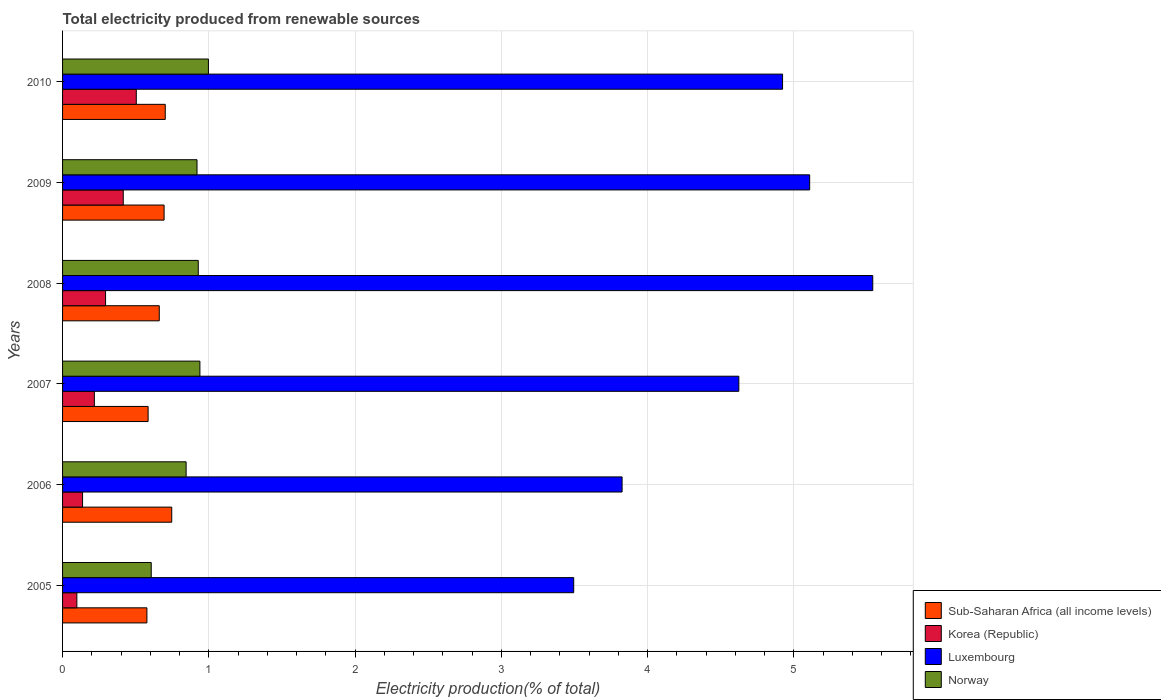How many different coloured bars are there?
Make the answer very short. 4. How many groups of bars are there?
Your answer should be very brief. 6. Are the number of bars per tick equal to the number of legend labels?
Provide a succinct answer. Yes. Are the number of bars on each tick of the Y-axis equal?
Your answer should be very brief. Yes. How many bars are there on the 2nd tick from the bottom?
Keep it short and to the point. 4. In how many cases, is the number of bars for a given year not equal to the number of legend labels?
Offer a very short reply. 0. What is the total electricity produced in Sub-Saharan Africa (all income levels) in 2006?
Provide a succinct answer. 0.75. Across all years, what is the maximum total electricity produced in Luxembourg?
Provide a succinct answer. 5.54. Across all years, what is the minimum total electricity produced in Luxembourg?
Your response must be concise. 3.49. What is the total total electricity produced in Norway in the graph?
Make the answer very short. 5.23. What is the difference between the total electricity produced in Norway in 2006 and that in 2007?
Ensure brevity in your answer.  -0.09. What is the difference between the total electricity produced in Sub-Saharan Africa (all income levels) in 2005 and the total electricity produced in Korea (Republic) in 2007?
Your response must be concise. 0.36. What is the average total electricity produced in Korea (Republic) per year?
Provide a succinct answer. 0.28. In the year 2009, what is the difference between the total electricity produced in Luxembourg and total electricity produced in Sub-Saharan Africa (all income levels)?
Your response must be concise. 4.41. In how many years, is the total electricity produced in Luxembourg greater than 1.6 %?
Offer a terse response. 6. What is the ratio of the total electricity produced in Sub-Saharan Africa (all income levels) in 2007 to that in 2009?
Keep it short and to the point. 0.84. What is the difference between the highest and the second highest total electricity produced in Norway?
Your answer should be very brief. 0.06. What is the difference between the highest and the lowest total electricity produced in Luxembourg?
Your response must be concise. 2.04. In how many years, is the total electricity produced in Luxembourg greater than the average total electricity produced in Luxembourg taken over all years?
Provide a succinct answer. 4. What does the 2nd bar from the top in 2009 represents?
Ensure brevity in your answer.  Luxembourg. What does the 3rd bar from the bottom in 2010 represents?
Ensure brevity in your answer.  Luxembourg. Is it the case that in every year, the sum of the total electricity produced in Luxembourg and total electricity produced in Korea (Republic) is greater than the total electricity produced in Sub-Saharan Africa (all income levels)?
Your answer should be very brief. Yes. How many bars are there?
Make the answer very short. 24. Does the graph contain any zero values?
Ensure brevity in your answer.  No. Where does the legend appear in the graph?
Provide a short and direct response. Bottom right. How many legend labels are there?
Make the answer very short. 4. What is the title of the graph?
Provide a succinct answer. Total electricity produced from renewable sources. Does "East Asia (all income levels)" appear as one of the legend labels in the graph?
Offer a terse response. No. What is the label or title of the Y-axis?
Make the answer very short. Years. What is the Electricity production(% of total) of Sub-Saharan Africa (all income levels) in 2005?
Keep it short and to the point. 0.58. What is the Electricity production(% of total) of Korea (Republic) in 2005?
Ensure brevity in your answer.  0.1. What is the Electricity production(% of total) of Luxembourg in 2005?
Provide a short and direct response. 3.49. What is the Electricity production(% of total) of Norway in 2005?
Your answer should be compact. 0.61. What is the Electricity production(% of total) in Sub-Saharan Africa (all income levels) in 2006?
Offer a terse response. 0.75. What is the Electricity production(% of total) of Korea (Republic) in 2006?
Give a very brief answer. 0.14. What is the Electricity production(% of total) in Luxembourg in 2006?
Your answer should be very brief. 3.83. What is the Electricity production(% of total) in Norway in 2006?
Provide a short and direct response. 0.84. What is the Electricity production(% of total) of Sub-Saharan Africa (all income levels) in 2007?
Your answer should be compact. 0.58. What is the Electricity production(% of total) in Korea (Republic) in 2007?
Keep it short and to the point. 0.22. What is the Electricity production(% of total) of Luxembourg in 2007?
Give a very brief answer. 4.62. What is the Electricity production(% of total) of Norway in 2007?
Offer a very short reply. 0.94. What is the Electricity production(% of total) of Sub-Saharan Africa (all income levels) in 2008?
Give a very brief answer. 0.66. What is the Electricity production(% of total) in Korea (Republic) in 2008?
Your answer should be very brief. 0.29. What is the Electricity production(% of total) in Luxembourg in 2008?
Your answer should be very brief. 5.54. What is the Electricity production(% of total) in Norway in 2008?
Provide a succinct answer. 0.93. What is the Electricity production(% of total) of Sub-Saharan Africa (all income levels) in 2009?
Keep it short and to the point. 0.69. What is the Electricity production(% of total) of Korea (Republic) in 2009?
Give a very brief answer. 0.41. What is the Electricity production(% of total) in Luxembourg in 2009?
Ensure brevity in your answer.  5.11. What is the Electricity production(% of total) of Norway in 2009?
Your answer should be compact. 0.92. What is the Electricity production(% of total) in Sub-Saharan Africa (all income levels) in 2010?
Give a very brief answer. 0.7. What is the Electricity production(% of total) in Korea (Republic) in 2010?
Your response must be concise. 0.5. What is the Electricity production(% of total) in Luxembourg in 2010?
Make the answer very short. 4.92. What is the Electricity production(% of total) in Norway in 2010?
Provide a succinct answer. 1. Across all years, what is the maximum Electricity production(% of total) of Sub-Saharan Africa (all income levels)?
Make the answer very short. 0.75. Across all years, what is the maximum Electricity production(% of total) in Korea (Republic)?
Provide a succinct answer. 0.5. Across all years, what is the maximum Electricity production(% of total) of Luxembourg?
Provide a short and direct response. 5.54. Across all years, what is the maximum Electricity production(% of total) in Norway?
Provide a succinct answer. 1. Across all years, what is the minimum Electricity production(% of total) of Sub-Saharan Africa (all income levels)?
Provide a succinct answer. 0.58. Across all years, what is the minimum Electricity production(% of total) in Korea (Republic)?
Make the answer very short. 0.1. Across all years, what is the minimum Electricity production(% of total) in Luxembourg?
Offer a terse response. 3.49. Across all years, what is the minimum Electricity production(% of total) of Norway?
Provide a short and direct response. 0.61. What is the total Electricity production(% of total) in Sub-Saharan Africa (all income levels) in the graph?
Offer a terse response. 3.97. What is the total Electricity production(% of total) in Korea (Republic) in the graph?
Your answer should be very brief. 1.66. What is the total Electricity production(% of total) in Luxembourg in the graph?
Your response must be concise. 27.51. What is the total Electricity production(% of total) in Norway in the graph?
Offer a terse response. 5.23. What is the difference between the Electricity production(% of total) in Sub-Saharan Africa (all income levels) in 2005 and that in 2006?
Your response must be concise. -0.17. What is the difference between the Electricity production(% of total) of Korea (Republic) in 2005 and that in 2006?
Your answer should be compact. -0.04. What is the difference between the Electricity production(% of total) in Luxembourg in 2005 and that in 2006?
Offer a terse response. -0.33. What is the difference between the Electricity production(% of total) of Norway in 2005 and that in 2006?
Your response must be concise. -0.24. What is the difference between the Electricity production(% of total) in Sub-Saharan Africa (all income levels) in 2005 and that in 2007?
Make the answer very short. -0.01. What is the difference between the Electricity production(% of total) in Korea (Republic) in 2005 and that in 2007?
Your response must be concise. -0.12. What is the difference between the Electricity production(% of total) in Luxembourg in 2005 and that in 2007?
Your answer should be compact. -1.13. What is the difference between the Electricity production(% of total) in Norway in 2005 and that in 2007?
Your answer should be compact. -0.33. What is the difference between the Electricity production(% of total) of Sub-Saharan Africa (all income levels) in 2005 and that in 2008?
Ensure brevity in your answer.  -0.08. What is the difference between the Electricity production(% of total) in Korea (Republic) in 2005 and that in 2008?
Offer a terse response. -0.2. What is the difference between the Electricity production(% of total) in Luxembourg in 2005 and that in 2008?
Your answer should be very brief. -2.04. What is the difference between the Electricity production(% of total) in Norway in 2005 and that in 2008?
Provide a short and direct response. -0.32. What is the difference between the Electricity production(% of total) in Sub-Saharan Africa (all income levels) in 2005 and that in 2009?
Your answer should be very brief. -0.12. What is the difference between the Electricity production(% of total) in Korea (Republic) in 2005 and that in 2009?
Provide a short and direct response. -0.32. What is the difference between the Electricity production(% of total) in Luxembourg in 2005 and that in 2009?
Provide a short and direct response. -1.61. What is the difference between the Electricity production(% of total) of Norway in 2005 and that in 2009?
Provide a short and direct response. -0.31. What is the difference between the Electricity production(% of total) of Sub-Saharan Africa (all income levels) in 2005 and that in 2010?
Give a very brief answer. -0.13. What is the difference between the Electricity production(% of total) in Korea (Republic) in 2005 and that in 2010?
Give a very brief answer. -0.41. What is the difference between the Electricity production(% of total) of Luxembourg in 2005 and that in 2010?
Your response must be concise. -1.43. What is the difference between the Electricity production(% of total) in Norway in 2005 and that in 2010?
Your answer should be compact. -0.39. What is the difference between the Electricity production(% of total) in Sub-Saharan Africa (all income levels) in 2006 and that in 2007?
Your answer should be compact. 0.16. What is the difference between the Electricity production(% of total) of Korea (Republic) in 2006 and that in 2007?
Your answer should be compact. -0.08. What is the difference between the Electricity production(% of total) in Luxembourg in 2006 and that in 2007?
Your answer should be very brief. -0.8. What is the difference between the Electricity production(% of total) in Norway in 2006 and that in 2007?
Offer a terse response. -0.09. What is the difference between the Electricity production(% of total) in Sub-Saharan Africa (all income levels) in 2006 and that in 2008?
Keep it short and to the point. 0.09. What is the difference between the Electricity production(% of total) in Korea (Republic) in 2006 and that in 2008?
Keep it short and to the point. -0.16. What is the difference between the Electricity production(% of total) in Luxembourg in 2006 and that in 2008?
Offer a very short reply. -1.71. What is the difference between the Electricity production(% of total) in Norway in 2006 and that in 2008?
Provide a short and direct response. -0.08. What is the difference between the Electricity production(% of total) in Sub-Saharan Africa (all income levels) in 2006 and that in 2009?
Provide a short and direct response. 0.05. What is the difference between the Electricity production(% of total) of Korea (Republic) in 2006 and that in 2009?
Offer a terse response. -0.28. What is the difference between the Electricity production(% of total) of Luxembourg in 2006 and that in 2009?
Offer a very short reply. -1.28. What is the difference between the Electricity production(% of total) of Norway in 2006 and that in 2009?
Give a very brief answer. -0.07. What is the difference between the Electricity production(% of total) of Sub-Saharan Africa (all income levels) in 2006 and that in 2010?
Provide a short and direct response. 0.04. What is the difference between the Electricity production(% of total) in Korea (Republic) in 2006 and that in 2010?
Offer a very short reply. -0.37. What is the difference between the Electricity production(% of total) of Luxembourg in 2006 and that in 2010?
Make the answer very short. -1.1. What is the difference between the Electricity production(% of total) in Norway in 2006 and that in 2010?
Your response must be concise. -0.15. What is the difference between the Electricity production(% of total) in Sub-Saharan Africa (all income levels) in 2007 and that in 2008?
Your answer should be very brief. -0.08. What is the difference between the Electricity production(% of total) of Korea (Republic) in 2007 and that in 2008?
Your answer should be very brief. -0.08. What is the difference between the Electricity production(% of total) in Luxembourg in 2007 and that in 2008?
Provide a succinct answer. -0.92. What is the difference between the Electricity production(% of total) of Norway in 2007 and that in 2008?
Provide a short and direct response. 0.01. What is the difference between the Electricity production(% of total) of Sub-Saharan Africa (all income levels) in 2007 and that in 2009?
Offer a very short reply. -0.11. What is the difference between the Electricity production(% of total) in Korea (Republic) in 2007 and that in 2009?
Ensure brevity in your answer.  -0.2. What is the difference between the Electricity production(% of total) in Luxembourg in 2007 and that in 2009?
Keep it short and to the point. -0.48. What is the difference between the Electricity production(% of total) of Norway in 2007 and that in 2009?
Ensure brevity in your answer.  0.02. What is the difference between the Electricity production(% of total) in Sub-Saharan Africa (all income levels) in 2007 and that in 2010?
Provide a short and direct response. -0.12. What is the difference between the Electricity production(% of total) in Korea (Republic) in 2007 and that in 2010?
Your answer should be very brief. -0.29. What is the difference between the Electricity production(% of total) of Luxembourg in 2007 and that in 2010?
Make the answer very short. -0.3. What is the difference between the Electricity production(% of total) in Norway in 2007 and that in 2010?
Keep it short and to the point. -0.06. What is the difference between the Electricity production(% of total) of Sub-Saharan Africa (all income levels) in 2008 and that in 2009?
Ensure brevity in your answer.  -0.03. What is the difference between the Electricity production(% of total) of Korea (Republic) in 2008 and that in 2009?
Provide a short and direct response. -0.12. What is the difference between the Electricity production(% of total) of Luxembourg in 2008 and that in 2009?
Your response must be concise. 0.43. What is the difference between the Electricity production(% of total) of Norway in 2008 and that in 2009?
Give a very brief answer. 0.01. What is the difference between the Electricity production(% of total) of Sub-Saharan Africa (all income levels) in 2008 and that in 2010?
Offer a very short reply. -0.04. What is the difference between the Electricity production(% of total) of Korea (Republic) in 2008 and that in 2010?
Provide a succinct answer. -0.21. What is the difference between the Electricity production(% of total) in Luxembourg in 2008 and that in 2010?
Make the answer very short. 0.62. What is the difference between the Electricity production(% of total) of Norway in 2008 and that in 2010?
Your answer should be very brief. -0.07. What is the difference between the Electricity production(% of total) in Sub-Saharan Africa (all income levels) in 2009 and that in 2010?
Keep it short and to the point. -0.01. What is the difference between the Electricity production(% of total) of Korea (Republic) in 2009 and that in 2010?
Ensure brevity in your answer.  -0.09. What is the difference between the Electricity production(% of total) in Luxembourg in 2009 and that in 2010?
Ensure brevity in your answer.  0.19. What is the difference between the Electricity production(% of total) of Norway in 2009 and that in 2010?
Your response must be concise. -0.08. What is the difference between the Electricity production(% of total) in Sub-Saharan Africa (all income levels) in 2005 and the Electricity production(% of total) in Korea (Republic) in 2006?
Your answer should be compact. 0.44. What is the difference between the Electricity production(% of total) in Sub-Saharan Africa (all income levels) in 2005 and the Electricity production(% of total) in Luxembourg in 2006?
Give a very brief answer. -3.25. What is the difference between the Electricity production(% of total) of Sub-Saharan Africa (all income levels) in 2005 and the Electricity production(% of total) of Norway in 2006?
Provide a short and direct response. -0.27. What is the difference between the Electricity production(% of total) in Korea (Republic) in 2005 and the Electricity production(% of total) in Luxembourg in 2006?
Offer a terse response. -3.73. What is the difference between the Electricity production(% of total) of Korea (Republic) in 2005 and the Electricity production(% of total) of Norway in 2006?
Offer a very short reply. -0.75. What is the difference between the Electricity production(% of total) in Luxembourg in 2005 and the Electricity production(% of total) in Norway in 2006?
Your answer should be very brief. 2.65. What is the difference between the Electricity production(% of total) of Sub-Saharan Africa (all income levels) in 2005 and the Electricity production(% of total) of Korea (Republic) in 2007?
Make the answer very short. 0.36. What is the difference between the Electricity production(% of total) in Sub-Saharan Africa (all income levels) in 2005 and the Electricity production(% of total) in Luxembourg in 2007?
Your response must be concise. -4.05. What is the difference between the Electricity production(% of total) in Sub-Saharan Africa (all income levels) in 2005 and the Electricity production(% of total) in Norway in 2007?
Your response must be concise. -0.36. What is the difference between the Electricity production(% of total) of Korea (Republic) in 2005 and the Electricity production(% of total) of Luxembourg in 2007?
Your answer should be compact. -4.53. What is the difference between the Electricity production(% of total) in Korea (Republic) in 2005 and the Electricity production(% of total) in Norway in 2007?
Give a very brief answer. -0.84. What is the difference between the Electricity production(% of total) in Luxembourg in 2005 and the Electricity production(% of total) in Norway in 2007?
Provide a succinct answer. 2.56. What is the difference between the Electricity production(% of total) in Sub-Saharan Africa (all income levels) in 2005 and the Electricity production(% of total) in Korea (Republic) in 2008?
Offer a terse response. 0.28. What is the difference between the Electricity production(% of total) in Sub-Saharan Africa (all income levels) in 2005 and the Electricity production(% of total) in Luxembourg in 2008?
Provide a short and direct response. -4.96. What is the difference between the Electricity production(% of total) in Sub-Saharan Africa (all income levels) in 2005 and the Electricity production(% of total) in Norway in 2008?
Keep it short and to the point. -0.35. What is the difference between the Electricity production(% of total) of Korea (Republic) in 2005 and the Electricity production(% of total) of Luxembourg in 2008?
Offer a very short reply. -5.44. What is the difference between the Electricity production(% of total) of Korea (Republic) in 2005 and the Electricity production(% of total) of Norway in 2008?
Your answer should be very brief. -0.83. What is the difference between the Electricity production(% of total) in Luxembourg in 2005 and the Electricity production(% of total) in Norway in 2008?
Keep it short and to the point. 2.57. What is the difference between the Electricity production(% of total) of Sub-Saharan Africa (all income levels) in 2005 and the Electricity production(% of total) of Korea (Republic) in 2009?
Offer a terse response. 0.16. What is the difference between the Electricity production(% of total) in Sub-Saharan Africa (all income levels) in 2005 and the Electricity production(% of total) in Luxembourg in 2009?
Give a very brief answer. -4.53. What is the difference between the Electricity production(% of total) in Sub-Saharan Africa (all income levels) in 2005 and the Electricity production(% of total) in Norway in 2009?
Ensure brevity in your answer.  -0.34. What is the difference between the Electricity production(% of total) of Korea (Republic) in 2005 and the Electricity production(% of total) of Luxembourg in 2009?
Offer a terse response. -5.01. What is the difference between the Electricity production(% of total) in Korea (Republic) in 2005 and the Electricity production(% of total) in Norway in 2009?
Make the answer very short. -0.82. What is the difference between the Electricity production(% of total) in Luxembourg in 2005 and the Electricity production(% of total) in Norway in 2009?
Give a very brief answer. 2.58. What is the difference between the Electricity production(% of total) of Sub-Saharan Africa (all income levels) in 2005 and the Electricity production(% of total) of Korea (Republic) in 2010?
Offer a very short reply. 0.07. What is the difference between the Electricity production(% of total) in Sub-Saharan Africa (all income levels) in 2005 and the Electricity production(% of total) in Luxembourg in 2010?
Your answer should be very brief. -4.35. What is the difference between the Electricity production(% of total) of Sub-Saharan Africa (all income levels) in 2005 and the Electricity production(% of total) of Norway in 2010?
Make the answer very short. -0.42. What is the difference between the Electricity production(% of total) in Korea (Republic) in 2005 and the Electricity production(% of total) in Luxembourg in 2010?
Offer a terse response. -4.82. What is the difference between the Electricity production(% of total) of Korea (Republic) in 2005 and the Electricity production(% of total) of Norway in 2010?
Ensure brevity in your answer.  -0.9. What is the difference between the Electricity production(% of total) in Luxembourg in 2005 and the Electricity production(% of total) in Norway in 2010?
Give a very brief answer. 2.5. What is the difference between the Electricity production(% of total) in Sub-Saharan Africa (all income levels) in 2006 and the Electricity production(% of total) in Korea (Republic) in 2007?
Provide a short and direct response. 0.53. What is the difference between the Electricity production(% of total) of Sub-Saharan Africa (all income levels) in 2006 and the Electricity production(% of total) of Luxembourg in 2007?
Your answer should be very brief. -3.88. What is the difference between the Electricity production(% of total) in Sub-Saharan Africa (all income levels) in 2006 and the Electricity production(% of total) in Norway in 2007?
Offer a very short reply. -0.19. What is the difference between the Electricity production(% of total) in Korea (Republic) in 2006 and the Electricity production(% of total) in Luxembourg in 2007?
Offer a very short reply. -4.49. What is the difference between the Electricity production(% of total) in Korea (Republic) in 2006 and the Electricity production(% of total) in Norway in 2007?
Provide a succinct answer. -0.8. What is the difference between the Electricity production(% of total) of Luxembourg in 2006 and the Electricity production(% of total) of Norway in 2007?
Keep it short and to the point. 2.89. What is the difference between the Electricity production(% of total) of Sub-Saharan Africa (all income levels) in 2006 and the Electricity production(% of total) of Korea (Republic) in 2008?
Offer a very short reply. 0.45. What is the difference between the Electricity production(% of total) in Sub-Saharan Africa (all income levels) in 2006 and the Electricity production(% of total) in Luxembourg in 2008?
Make the answer very short. -4.79. What is the difference between the Electricity production(% of total) of Sub-Saharan Africa (all income levels) in 2006 and the Electricity production(% of total) of Norway in 2008?
Offer a terse response. -0.18. What is the difference between the Electricity production(% of total) in Korea (Republic) in 2006 and the Electricity production(% of total) in Luxembourg in 2008?
Provide a short and direct response. -5.4. What is the difference between the Electricity production(% of total) of Korea (Republic) in 2006 and the Electricity production(% of total) of Norway in 2008?
Provide a succinct answer. -0.79. What is the difference between the Electricity production(% of total) of Luxembourg in 2006 and the Electricity production(% of total) of Norway in 2008?
Offer a terse response. 2.9. What is the difference between the Electricity production(% of total) of Sub-Saharan Africa (all income levels) in 2006 and the Electricity production(% of total) of Korea (Republic) in 2009?
Make the answer very short. 0.33. What is the difference between the Electricity production(% of total) of Sub-Saharan Africa (all income levels) in 2006 and the Electricity production(% of total) of Luxembourg in 2009?
Make the answer very short. -4.36. What is the difference between the Electricity production(% of total) in Sub-Saharan Africa (all income levels) in 2006 and the Electricity production(% of total) in Norway in 2009?
Make the answer very short. -0.17. What is the difference between the Electricity production(% of total) in Korea (Republic) in 2006 and the Electricity production(% of total) in Luxembourg in 2009?
Provide a succinct answer. -4.97. What is the difference between the Electricity production(% of total) of Korea (Republic) in 2006 and the Electricity production(% of total) of Norway in 2009?
Provide a succinct answer. -0.78. What is the difference between the Electricity production(% of total) of Luxembourg in 2006 and the Electricity production(% of total) of Norway in 2009?
Provide a succinct answer. 2.91. What is the difference between the Electricity production(% of total) in Sub-Saharan Africa (all income levels) in 2006 and the Electricity production(% of total) in Korea (Republic) in 2010?
Keep it short and to the point. 0.24. What is the difference between the Electricity production(% of total) of Sub-Saharan Africa (all income levels) in 2006 and the Electricity production(% of total) of Luxembourg in 2010?
Give a very brief answer. -4.18. What is the difference between the Electricity production(% of total) of Sub-Saharan Africa (all income levels) in 2006 and the Electricity production(% of total) of Norway in 2010?
Provide a short and direct response. -0.25. What is the difference between the Electricity production(% of total) in Korea (Republic) in 2006 and the Electricity production(% of total) in Luxembourg in 2010?
Ensure brevity in your answer.  -4.79. What is the difference between the Electricity production(% of total) of Korea (Republic) in 2006 and the Electricity production(% of total) of Norway in 2010?
Keep it short and to the point. -0.86. What is the difference between the Electricity production(% of total) of Luxembourg in 2006 and the Electricity production(% of total) of Norway in 2010?
Your answer should be compact. 2.83. What is the difference between the Electricity production(% of total) in Sub-Saharan Africa (all income levels) in 2007 and the Electricity production(% of total) in Korea (Republic) in 2008?
Provide a short and direct response. 0.29. What is the difference between the Electricity production(% of total) of Sub-Saharan Africa (all income levels) in 2007 and the Electricity production(% of total) of Luxembourg in 2008?
Make the answer very short. -4.95. What is the difference between the Electricity production(% of total) in Sub-Saharan Africa (all income levels) in 2007 and the Electricity production(% of total) in Norway in 2008?
Your answer should be compact. -0.34. What is the difference between the Electricity production(% of total) of Korea (Republic) in 2007 and the Electricity production(% of total) of Luxembourg in 2008?
Provide a succinct answer. -5.32. What is the difference between the Electricity production(% of total) in Korea (Republic) in 2007 and the Electricity production(% of total) in Norway in 2008?
Give a very brief answer. -0.71. What is the difference between the Electricity production(% of total) of Luxembourg in 2007 and the Electricity production(% of total) of Norway in 2008?
Your answer should be very brief. 3.7. What is the difference between the Electricity production(% of total) of Sub-Saharan Africa (all income levels) in 2007 and the Electricity production(% of total) of Korea (Republic) in 2009?
Your response must be concise. 0.17. What is the difference between the Electricity production(% of total) in Sub-Saharan Africa (all income levels) in 2007 and the Electricity production(% of total) in Luxembourg in 2009?
Offer a terse response. -4.52. What is the difference between the Electricity production(% of total) in Sub-Saharan Africa (all income levels) in 2007 and the Electricity production(% of total) in Norway in 2009?
Provide a short and direct response. -0.33. What is the difference between the Electricity production(% of total) in Korea (Republic) in 2007 and the Electricity production(% of total) in Luxembourg in 2009?
Provide a succinct answer. -4.89. What is the difference between the Electricity production(% of total) of Korea (Republic) in 2007 and the Electricity production(% of total) of Norway in 2009?
Offer a terse response. -0.7. What is the difference between the Electricity production(% of total) in Luxembourg in 2007 and the Electricity production(% of total) in Norway in 2009?
Your response must be concise. 3.7. What is the difference between the Electricity production(% of total) of Sub-Saharan Africa (all income levels) in 2007 and the Electricity production(% of total) of Korea (Republic) in 2010?
Offer a very short reply. 0.08. What is the difference between the Electricity production(% of total) of Sub-Saharan Africa (all income levels) in 2007 and the Electricity production(% of total) of Luxembourg in 2010?
Ensure brevity in your answer.  -4.34. What is the difference between the Electricity production(% of total) of Sub-Saharan Africa (all income levels) in 2007 and the Electricity production(% of total) of Norway in 2010?
Your response must be concise. -0.41. What is the difference between the Electricity production(% of total) of Korea (Republic) in 2007 and the Electricity production(% of total) of Luxembourg in 2010?
Provide a succinct answer. -4.71. What is the difference between the Electricity production(% of total) in Korea (Republic) in 2007 and the Electricity production(% of total) in Norway in 2010?
Your answer should be compact. -0.78. What is the difference between the Electricity production(% of total) of Luxembourg in 2007 and the Electricity production(% of total) of Norway in 2010?
Make the answer very short. 3.63. What is the difference between the Electricity production(% of total) of Sub-Saharan Africa (all income levels) in 2008 and the Electricity production(% of total) of Korea (Republic) in 2009?
Ensure brevity in your answer.  0.25. What is the difference between the Electricity production(% of total) in Sub-Saharan Africa (all income levels) in 2008 and the Electricity production(% of total) in Luxembourg in 2009?
Your response must be concise. -4.45. What is the difference between the Electricity production(% of total) of Sub-Saharan Africa (all income levels) in 2008 and the Electricity production(% of total) of Norway in 2009?
Provide a succinct answer. -0.26. What is the difference between the Electricity production(% of total) in Korea (Republic) in 2008 and the Electricity production(% of total) in Luxembourg in 2009?
Keep it short and to the point. -4.81. What is the difference between the Electricity production(% of total) of Korea (Republic) in 2008 and the Electricity production(% of total) of Norway in 2009?
Keep it short and to the point. -0.63. What is the difference between the Electricity production(% of total) of Luxembourg in 2008 and the Electricity production(% of total) of Norway in 2009?
Keep it short and to the point. 4.62. What is the difference between the Electricity production(% of total) in Sub-Saharan Africa (all income levels) in 2008 and the Electricity production(% of total) in Korea (Republic) in 2010?
Keep it short and to the point. 0.16. What is the difference between the Electricity production(% of total) in Sub-Saharan Africa (all income levels) in 2008 and the Electricity production(% of total) in Luxembourg in 2010?
Your response must be concise. -4.26. What is the difference between the Electricity production(% of total) in Sub-Saharan Africa (all income levels) in 2008 and the Electricity production(% of total) in Norway in 2010?
Ensure brevity in your answer.  -0.34. What is the difference between the Electricity production(% of total) of Korea (Republic) in 2008 and the Electricity production(% of total) of Luxembourg in 2010?
Keep it short and to the point. -4.63. What is the difference between the Electricity production(% of total) in Korea (Republic) in 2008 and the Electricity production(% of total) in Norway in 2010?
Offer a very short reply. -0.7. What is the difference between the Electricity production(% of total) in Luxembourg in 2008 and the Electricity production(% of total) in Norway in 2010?
Your response must be concise. 4.54. What is the difference between the Electricity production(% of total) in Sub-Saharan Africa (all income levels) in 2009 and the Electricity production(% of total) in Korea (Republic) in 2010?
Your answer should be very brief. 0.19. What is the difference between the Electricity production(% of total) of Sub-Saharan Africa (all income levels) in 2009 and the Electricity production(% of total) of Luxembourg in 2010?
Give a very brief answer. -4.23. What is the difference between the Electricity production(% of total) of Sub-Saharan Africa (all income levels) in 2009 and the Electricity production(% of total) of Norway in 2010?
Make the answer very short. -0.3. What is the difference between the Electricity production(% of total) of Korea (Republic) in 2009 and the Electricity production(% of total) of Luxembourg in 2010?
Offer a very short reply. -4.51. What is the difference between the Electricity production(% of total) of Korea (Republic) in 2009 and the Electricity production(% of total) of Norway in 2010?
Your answer should be compact. -0.58. What is the difference between the Electricity production(% of total) in Luxembourg in 2009 and the Electricity production(% of total) in Norway in 2010?
Offer a terse response. 4.11. What is the average Electricity production(% of total) in Sub-Saharan Africa (all income levels) per year?
Provide a succinct answer. 0.66. What is the average Electricity production(% of total) of Korea (Republic) per year?
Offer a terse response. 0.28. What is the average Electricity production(% of total) of Luxembourg per year?
Keep it short and to the point. 4.59. What is the average Electricity production(% of total) of Norway per year?
Provide a short and direct response. 0.87. In the year 2005, what is the difference between the Electricity production(% of total) in Sub-Saharan Africa (all income levels) and Electricity production(% of total) in Korea (Republic)?
Give a very brief answer. 0.48. In the year 2005, what is the difference between the Electricity production(% of total) in Sub-Saharan Africa (all income levels) and Electricity production(% of total) in Luxembourg?
Your answer should be compact. -2.92. In the year 2005, what is the difference between the Electricity production(% of total) of Sub-Saharan Africa (all income levels) and Electricity production(% of total) of Norway?
Give a very brief answer. -0.03. In the year 2005, what is the difference between the Electricity production(% of total) in Korea (Republic) and Electricity production(% of total) in Luxembourg?
Offer a terse response. -3.4. In the year 2005, what is the difference between the Electricity production(% of total) in Korea (Republic) and Electricity production(% of total) in Norway?
Your answer should be very brief. -0.51. In the year 2005, what is the difference between the Electricity production(% of total) in Luxembourg and Electricity production(% of total) in Norway?
Offer a very short reply. 2.89. In the year 2006, what is the difference between the Electricity production(% of total) in Sub-Saharan Africa (all income levels) and Electricity production(% of total) in Korea (Republic)?
Keep it short and to the point. 0.61. In the year 2006, what is the difference between the Electricity production(% of total) of Sub-Saharan Africa (all income levels) and Electricity production(% of total) of Luxembourg?
Your response must be concise. -3.08. In the year 2006, what is the difference between the Electricity production(% of total) of Sub-Saharan Africa (all income levels) and Electricity production(% of total) of Norway?
Provide a short and direct response. -0.1. In the year 2006, what is the difference between the Electricity production(% of total) of Korea (Republic) and Electricity production(% of total) of Luxembourg?
Ensure brevity in your answer.  -3.69. In the year 2006, what is the difference between the Electricity production(% of total) in Korea (Republic) and Electricity production(% of total) in Norway?
Your answer should be very brief. -0.71. In the year 2006, what is the difference between the Electricity production(% of total) in Luxembourg and Electricity production(% of total) in Norway?
Offer a very short reply. 2.98. In the year 2007, what is the difference between the Electricity production(% of total) of Sub-Saharan Africa (all income levels) and Electricity production(% of total) of Korea (Republic)?
Keep it short and to the point. 0.37. In the year 2007, what is the difference between the Electricity production(% of total) of Sub-Saharan Africa (all income levels) and Electricity production(% of total) of Luxembourg?
Make the answer very short. -4.04. In the year 2007, what is the difference between the Electricity production(% of total) of Sub-Saharan Africa (all income levels) and Electricity production(% of total) of Norway?
Provide a succinct answer. -0.35. In the year 2007, what is the difference between the Electricity production(% of total) of Korea (Republic) and Electricity production(% of total) of Luxembourg?
Provide a succinct answer. -4.41. In the year 2007, what is the difference between the Electricity production(% of total) in Korea (Republic) and Electricity production(% of total) in Norway?
Your answer should be very brief. -0.72. In the year 2007, what is the difference between the Electricity production(% of total) of Luxembourg and Electricity production(% of total) of Norway?
Your response must be concise. 3.68. In the year 2008, what is the difference between the Electricity production(% of total) in Sub-Saharan Africa (all income levels) and Electricity production(% of total) in Korea (Republic)?
Make the answer very short. 0.37. In the year 2008, what is the difference between the Electricity production(% of total) in Sub-Saharan Africa (all income levels) and Electricity production(% of total) in Luxembourg?
Your answer should be compact. -4.88. In the year 2008, what is the difference between the Electricity production(% of total) in Sub-Saharan Africa (all income levels) and Electricity production(% of total) in Norway?
Provide a short and direct response. -0.27. In the year 2008, what is the difference between the Electricity production(% of total) in Korea (Republic) and Electricity production(% of total) in Luxembourg?
Your answer should be compact. -5.25. In the year 2008, what is the difference between the Electricity production(% of total) in Korea (Republic) and Electricity production(% of total) in Norway?
Offer a very short reply. -0.63. In the year 2008, what is the difference between the Electricity production(% of total) in Luxembourg and Electricity production(% of total) in Norway?
Provide a succinct answer. 4.61. In the year 2009, what is the difference between the Electricity production(% of total) of Sub-Saharan Africa (all income levels) and Electricity production(% of total) of Korea (Republic)?
Offer a terse response. 0.28. In the year 2009, what is the difference between the Electricity production(% of total) in Sub-Saharan Africa (all income levels) and Electricity production(% of total) in Luxembourg?
Provide a short and direct response. -4.41. In the year 2009, what is the difference between the Electricity production(% of total) in Sub-Saharan Africa (all income levels) and Electricity production(% of total) in Norway?
Give a very brief answer. -0.23. In the year 2009, what is the difference between the Electricity production(% of total) in Korea (Republic) and Electricity production(% of total) in Luxembourg?
Your answer should be very brief. -4.69. In the year 2009, what is the difference between the Electricity production(% of total) in Korea (Republic) and Electricity production(% of total) in Norway?
Provide a succinct answer. -0.5. In the year 2009, what is the difference between the Electricity production(% of total) in Luxembourg and Electricity production(% of total) in Norway?
Offer a terse response. 4.19. In the year 2010, what is the difference between the Electricity production(% of total) in Sub-Saharan Africa (all income levels) and Electricity production(% of total) in Korea (Republic)?
Offer a very short reply. 0.2. In the year 2010, what is the difference between the Electricity production(% of total) of Sub-Saharan Africa (all income levels) and Electricity production(% of total) of Luxembourg?
Ensure brevity in your answer.  -4.22. In the year 2010, what is the difference between the Electricity production(% of total) of Sub-Saharan Africa (all income levels) and Electricity production(% of total) of Norway?
Offer a very short reply. -0.3. In the year 2010, what is the difference between the Electricity production(% of total) in Korea (Republic) and Electricity production(% of total) in Luxembourg?
Offer a terse response. -4.42. In the year 2010, what is the difference between the Electricity production(% of total) of Korea (Republic) and Electricity production(% of total) of Norway?
Keep it short and to the point. -0.49. In the year 2010, what is the difference between the Electricity production(% of total) in Luxembourg and Electricity production(% of total) in Norway?
Your response must be concise. 3.93. What is the ratio of the Electricity production(% of total) of Sub-Saharan Africa (all income levels) in 2005 to that in 2006?
Ensure brevity in your answer.  0.77. What is the ratio of the Electricity production(% of total) of Korea (Republic) in 2005 to that in 2006?
Give a very brief answer. 0.71. What is the ratio of the Electricity production(% of total) of Luxembourg in 2005 to that in 2006?
Offer a terse response. 0.91. What is the ratio of the Electricity production(% of total) in Norway in 2005 to that in 2006?
Offer a terse response. 0.72. What is the ratio of the Electricity production(% of total) in Sub-Saharan Africa (all income levels) in 2005 to that in 2007?
Keep it short and to the point. 0.99. What is the ratio of the Electricity production(% of total) of Korea (Republic) in 2005 to that in 2007?
Offer a very short reply. 0.45. What is the ratio of the Electricity production(% of total) in Luxembourg in 2005 to that in 2007?
Give a very brief answer. 0.76. What is the ratio of the Electricity production(% of total) in Norway in 2005 to that in 2007?
Provide a succinct answer. 0.65. What is the ratio of the Electricity production(% of total) of Sub-Saharan Africa (all income levels) in 2005 to that in 2008?
Provide a succinct answer. 0.87. What is the ratio of the Electricity production(% of total) in Korea (Republic) in 2005 to that in 2008?
Make the answer very short. 0.33. What is the ratio of the Electricity production(% of total) of Luxembourg in 2005 to that in 2008?
Your answer should be compact. 0.63. What is the ratio of the Electricity production(% of total) in Norway in 2005 to that in 2008?
Offer a very short reply. 0.65. What is the ratio of the Electricity production(% of total) in Sub-Saharan Africa (all income levels) in 2005 to that in 2009?
Offer a very short reply. 0.83. What is the ratio of the Electricity production(% of total) of Korea (Republic) in 2005 to that in 2009?
Ensure brevity in your answer.  0.24. What is the ratio of the Electricity production(% of total) in Luxembourg in 2005 to that in 2009?
Ensure brevity in your answer.  0.68. What is the ratio of the Electricity production(% of total) in Norway in 2005 to that in 2009?
Provide a short and direct response. 0.66. What is the ratio of the Electricity production(% of total) of Sub-Saharan Africa (all income levels) in 2005 to that in 2010?
Make the answer very short. 0.82. What is the ratio of the Electricity production(% of total) of Korea (Republic) in 2005 to that in 2010?
Your answer should be compact. 0.19. What is the ratio of the Electricity production(% of total) of Luxembourg in 2005 to that in 2010?
Give a very brief answer. 0.71. What is the ratio of the Electricity production(% of total) in Norway in 2005 to that in 2010?
Give a very brief answer. 0.61. What is the ratio of the Electricity production(% of total) in Sub-Saharan Africa (all income levels) in 2006 to that in 2007?
Ensure brevity in your answer.  1.28. What is the ratio of the Electricity production(% of total) of Korea (Republic) in 2006 to that in 2007?
Your response must be concise. 0.63. What is the ratio of the Electricity production(% of total) of Luxembourg in 2006 to that in 2007?
Give a very brief answer. 0.83. What is the ratio of the Electricity production(% of total) of Norway in 2006 to that in 2007?
Provide a short and direct response. 0.9. What is the ratio of the Electricity production(% of total) of Sub-Saharan Africa (all income levels) in 2006 to that in 2008?
Give a very brief answer. 1.13. What is the ratio of the Electricity production(% of total) in Korea (Republic) in 2006 to that in 2008?
Give a very brief answer. 0.47. What is the ratio of the Electricity production(% of total) of Luxembourg in 2006 to that in 2008?
Keep it short and to the point. 0.69. What is the ratio of the Electricity production(% of total) of Norway in 2006 to that in 2008?
Your answer should be very brief. 0.91. What is the ratio of the Electricity production(% of total) in Sub-Saharan Africa (all income levels) in 2006 to that in 2009?
Provide a short and direct response. 1.08. What is the ratio of the Electricity production(% of total) in Korea (Republic) in 2006 to that in 2009?
Ensure brevity in your answer.  0.33. What is the ratio of the Electricity production(% of total) in Luxembourg in 2006 to that in 2009?
Ensure brevity in your answer.  0.75. What is the ratio of the Electricity production(% of total) of Norway in 2006 to that in 2009?
Provide a succinct answer. 0.92. What is the ratio of the Electricity production(% of total) of Sub-Saharan Africa (all income levels) in 2006 to that in 2010?
Ensure brevity in your answer.  1.06. What is the ratio of the Electricity production(% of total) of Korea (Republic) in 2006 to that in 2010?
Make the answer very short. 0.27. What is the ratio of the Electricity production(% of total) of Luxembourg in 2006 to that in 2010?
Your response must be concise. 0.78. What is the ratio of the Electricity production(% of total) of Norway in 2006 to that in 2010?
Ensure brevity in your answer.  0.85. What is the ratio of the Electricity production(% of total) in Sub-Saharan Africa (all income levels) in 2007 to that in 2008?
Give a very brief answer. 0.88. What is the ratio of the Electricity production(% of total) in Korea (Republic) in 2007 to that in 2008?
Make the answer very short. 0.74. What is the ratio of the Electricity production(% of total) in Luxembourg in 2007 to that in 2008?
Your response must be concise. 0.83. What is the ratio of the Electricity production(% of total) of Norway in 2007 to that in 2008?
Your response must be concise. 1.01. What is the ratio of the Electricity production(% of total) in Sub-Saharan Africa (all income levels) in 2007 to that in 2009?
Ensure brevity in your answer.  0.84. What is the ratio of the Electricity production(% of total) in Korea (Republic) in 2007 to that in 2009?
Your response must be concise. 0.52. What is the ratio of the Electricity production(% of total) of Luxembourg in 2007 to that in 2009?
Offer a terse response. 0.91. What is the ratio of the Electricity production(% of total) in Norway in 2007 to that in 2009?
Your response must be concise. 1.02. What is the ratio of the Electricity production(% of total) in Sub-Saharan Africa (all income levels) in 2007 to that in 2010?
Offer a very short reply. 0.83. What is the ratio of the Electricity production(% of total) of Korea (Republic) in 2007 to that in 2010?
Provide a succinct answer. 0.43. What is the ratio of the Electricity production(% of total) in Luxembourg in 2007 to that in 2010?
Keep it short and to the point. 0.94. What is the ratio of the Electricity production(% of total) of Norway in 2007 to that in 2010?
Your answer should be compact. 0.94. What is the ratio of the Electricity production(% of total) in Sub-Saharan Africa (all income levels) in 2008 to that in 2009?
Offer a very short reply. 0.95. What is the ratio of the Electricity production(% of total) of Korea (Republic) in 2008 to that in 2009?
Keep it short and to the point. 0.71. What is the ratio of the Electricity production(% of total) in Luxembourg in 2008 to that in 2009?
Provide a succinct answer. 1.08. What is the ratio of the Electricity production(% of total) in Norway in 2008 to that in 2009?
Ensure brevity in your answer.  1.01. What is the ratio of the Electricity production(% of total) in Sub-Saharan Africa (all income levels) in 2008 to that in 2010?
Give a very brief answer. 0.94. What is the ratio of the Electricity production(% of total) of Korea (Republic) in 2008 to that in 2010?
Your answer should be compact. 0.58. What is the ratio of the Electricity production(% of total) in Luxembourg in 2008 to that in 2010?
Give a very brief answer. 1.13. What is the ratio of the Electricity production(% of total) in Norway in 2008 to that in 2010?
Offer a very short reply. 0.93. What is the ratio of the Electricity production(% of total) of Korea (Republic) in 2009 to that in 2010?
Ensure brevity in your answer.  0.82. What is the ratio of the Electricity production(% of total) of Luxembourg in 2009 to that in 2010?
Keep it short and to the point. 1.04. What is the ratio of the Electricity production(% of total) in Norway in 2009 to that in 2010?
Your answer should be compact. 0.92. What is the difference between the highest and the second highest Electricity production(% of total) in Sub-Saharan Africa (all income levels)?
Keep it short and to the point. 0.04. What is the difference between the highest and the second highest Electricity production(% of total) of Korea (Republic)?
Give a very brief answer. 0.09. What is the difference between the highest and the second highest Electricity production(% of total) in Luxembourg?
Make the answer very short. 0.43. What is the difference between the highest and the second highest Electricity production(% of total) of Norway?
Offer a very short reply. 0.06. What is the difference between the highest and the lowest Electricity production(% of total) of Sub-Saharan Africa (all income levels)?
Provide a short and direct response. 0.17. What is the difference between the highest and the lowest Electricity production(% of total) of Korea (Republic)?
Provide a succinct answer. 0.41. What is the difference between the highest and the lowest Electricity production(% of total) of Luxembourg?
Keep it short and to the point. 2.04. What is the difference between the highest and the lowest Electricity production(% of total) of Norway?
Your answer should be compact. 0.39. 